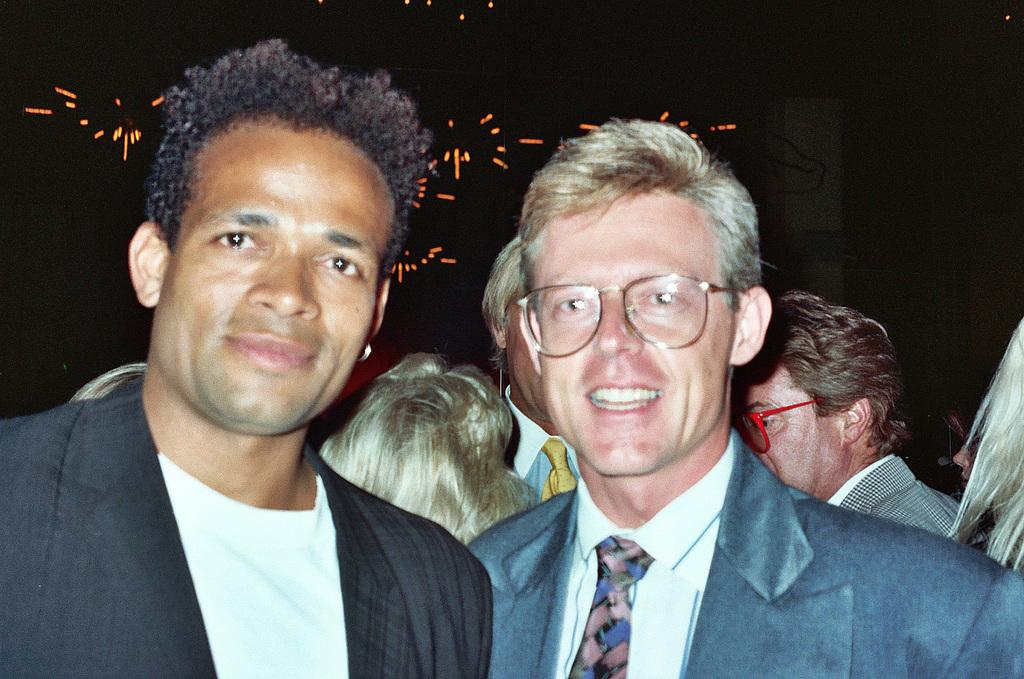How many people are present in the image? There are many people in the image. What can be seen in the background of the image? There are lights visible in the background of the image. What type of land is visible in the image? There is no land visible in the image; it features people and lights. How many cakes are present in the image? There is no mention of cakes in the image; it only features people and lights. 